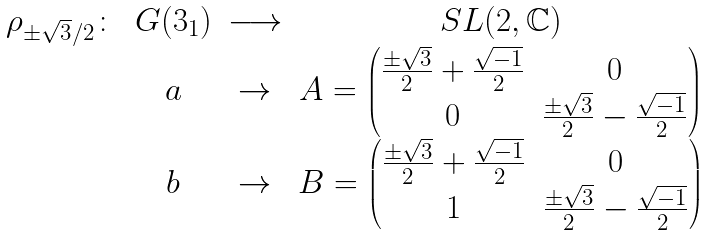<formula> <loc_0><loc_0><loc_500><loc_500>\begin{array} { c c c c } \rho _ { \pm \sqrt { 3 } / 2 } \colon & G ( 3 _ { 1 } ) & \longrightarrow & S L ( 2 , \mathbb { C } ) \\ & a & \rightarrow & A = \begin{pmatrix} \frac { \pm \sqrt { 3 } } { 2 } + \frac { \sqrt { - 1 } } { 2 } & 0 \\ 0 & \frac { \pm \sqrt { 3 } } { 2 } - \frac { \sqrt { - 1 } } { 2 } \end{pmatrix} \\ & b & \rightarrow & B = \begin{pmatrix} \frac { \pm \sqrt { 3 } } { 2 } + \frac { \sqrt { - 1 } } { 2 } & 0 \\ 1 & \frac { \pm \sqrt { 3 } } { 2 } - \frac { \sqrt { - 1 } } { 2 } \end{pmatrix} \end{array}</formula> 